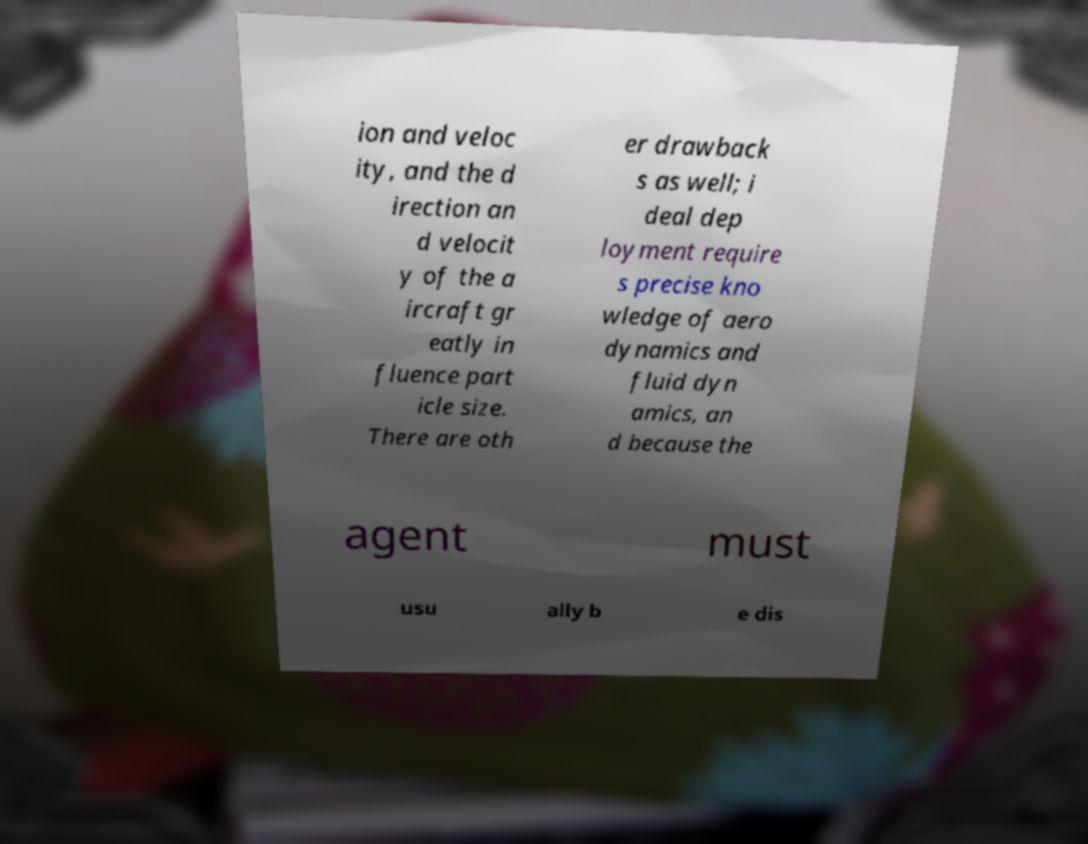Please read and relay the text visible in this image. What does it say? ion and veloc ity, and the d irection an d velocit y of the a ircraft gr eatly in fluence part icle size. There are oth er drawback s as well; i deal dep loyment require s precise kno wledge of aero dynamics and fluid dyn amics, an d because the agent must usu ally b e dis 